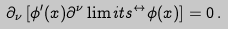Convert formula to latex. <formula><loc_0><loc_0><loc_500><loc_500>\partial _ { \nu } \left [ \phi ^ { \prime } ( x ) \partial ^ { \nu } \lim i t s ^ { \leftrightarrow } \phi ( x ) \right ] = 0 \, .</formula> 